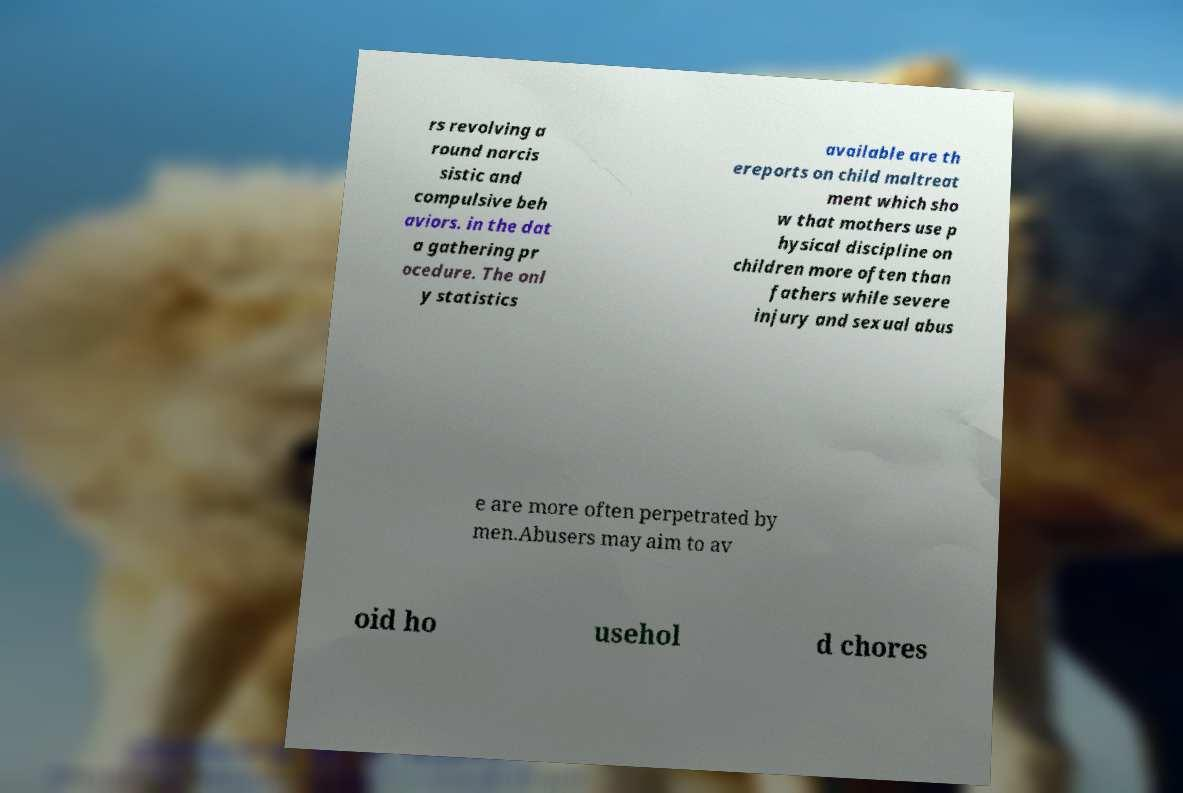Please identify and transcribe the text found in this image. rs revolving a round narcis sistic and compulsive beh aviors. in the dat a gathering pr ocedure. The onl y statistics available are th ereports on child maltreat ment which sho w that mothers use p hysical discipline on children more often than fathers while severe injury and sexual abus e are more often perpetrated by men.Abusers may aim to av oid ho usehol d chores 